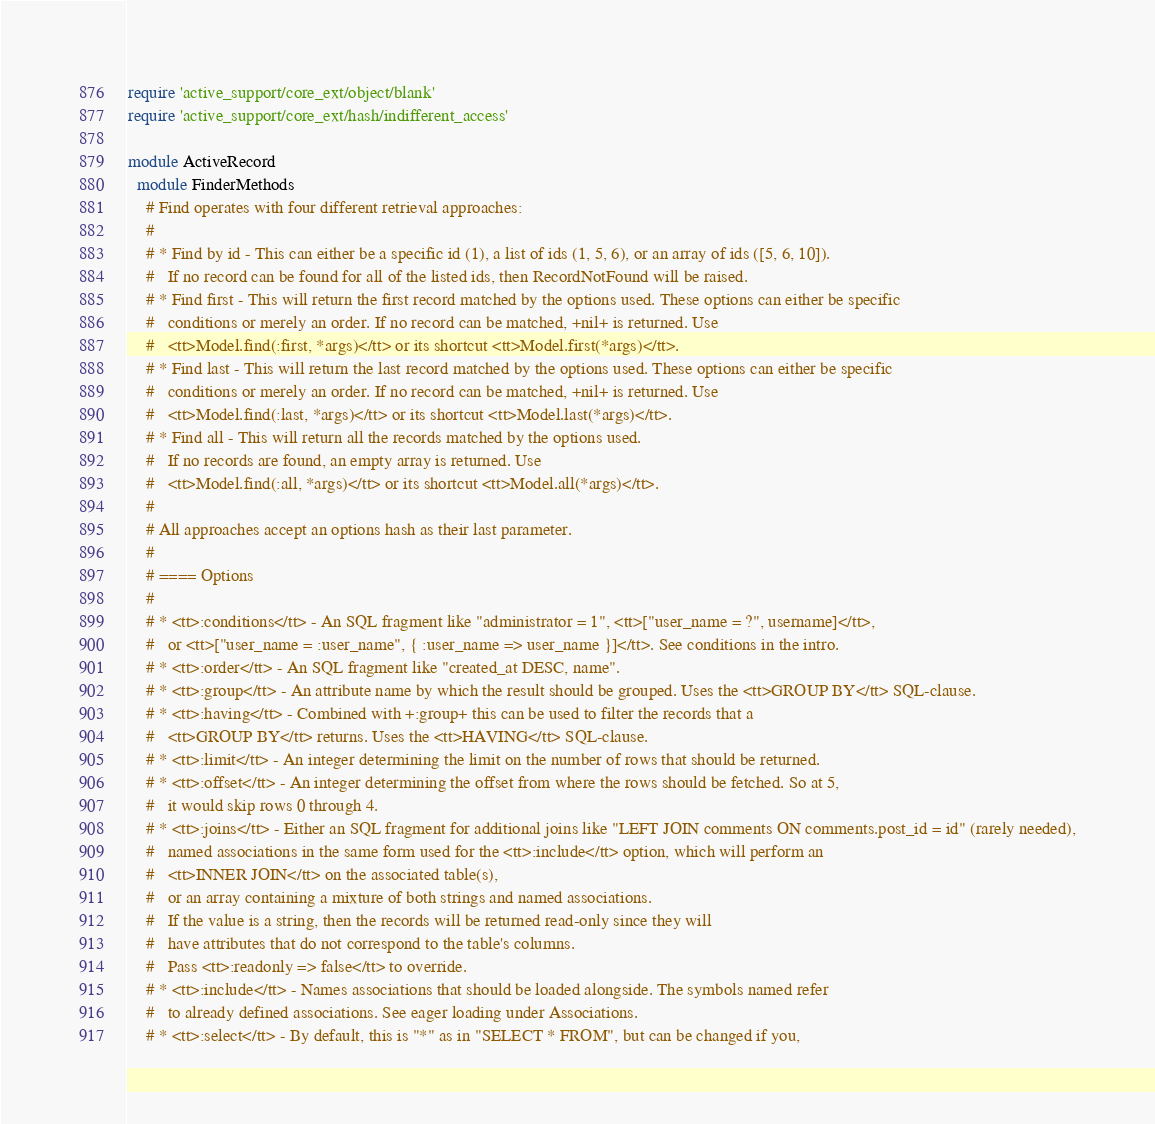<code> <loc_0><loc_0><loc_500><loc_500><_Ruby_>require 'active_support/core_ext/object/blank'
require 'active_support/core_ext/hash/indifferent_access'

module ActiveRecord
  module FinderMethods
    # Find operates with four different retrieval approaches:
    #
    # * Find by id - This can either be a specific id (1), a list of ids (1, 5, 6), or an array of ids ([5, 6, 10]).
    #   If no record can be found for all of the listed ids, then RecordNotFound will be raised.
    # * Find first - This will return the first record matched by the options used. These options can either be specific
    #   conditions or merely an order. If no record can be matched, +nil+ is returned. Use
    #   <tt>Model.find(:first, *args)</tt> or its shortcut <tt>Model.first(*args)</tt>.
    # * Find last - This will return the last record matched by the options used. These options can either be specific
    #   conditions or merely an order. If no record can be matched, +nil+ is returned. Use
    #   <tt>Model.find(:last, *args)</tt> or its shortcut <tt>Model.last(*args)</tt>.
    # * Find all - This will return all the records matched by the options used.
    #   If no records are found, an empty array is returned. Use
    #   <tt>Model.find(:all, *args)</tt> or its shortcut <tt>Model.all(*args)</tt>.
    #
    # All approaches accept an options hash as their last parameter.
    #
    # ==== Options
    #
    # * <tt>:conditions</tt> - An SQL fragment like "administrator = 1", <tt>["user_name = ?", username]</tt>,
    #   or <tt>["user_name = :user_name", { :user_name => user_name }]</tt>. See conditions in the intro.
    # * <tt>:order</tt> - An SQL fragment like "created_at DESC, name".
    # * <tt>:group</tt> - An attribute name by which the result should be grouped. Uses the <tt>GROUP BY</tt> SQL-clause.
    # * <tt>:having</tt> - Combined with +:group+ this can be used to filter the records that a
    #   <tt>GROUP BY</tt> returns. Uses the <tt>HAVING</tt> SQL-clause.
    # * <tt>:limit</tt> - An integer determining the limit on the number of rows that should be returned.
    # * <tt>:offset</tt> - An integer determining the offset from where the rows should be fetched. So at 5,
    #   it would skip rows 0 through 4.
    # * <tt>:joins</tt> - Either an SQL fragment for additional joins like "LEFT JOIN comments ON comments.post_id = id" (rarely needed),
    #   named associations in the same form used for the <tt>:include</tt> option, which will perform an
    #   <tt>INNER JOIN</tt> on the associated table(s),
    #   or an array containing a mixture of both strings and named associations.
    #   If the value is a string, then the records will be returned read-only since they will
    #   have attributes that do not correspond to the table's columns.
    #   Pass <tt>:readonly => false</tt> to override.
    # * <tt>:include</tt> - Names associations that should be loaded alongside. The symbols named refer
    #   to already defined associations. See eager loading under Associations.
    # * <tt>:select</tt> - By default, this is "*" as in "SELECT * FROM", but can be changed if you,</code> 